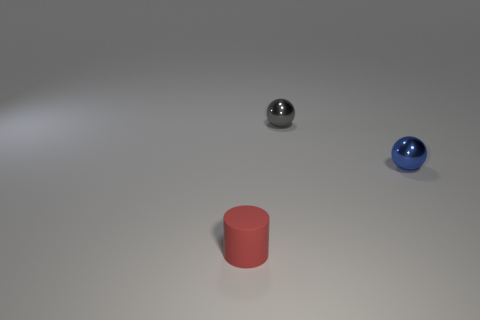What materials are the objects in the image made of? The objects appear to be made of different materials. The shiny ball on the left seems to be metallic, possibly steel or aluminum, while the blue ball looks like it could be either painted metal or plastic. The red cylinder has a matte finish that suggests it could be made of plastic. 